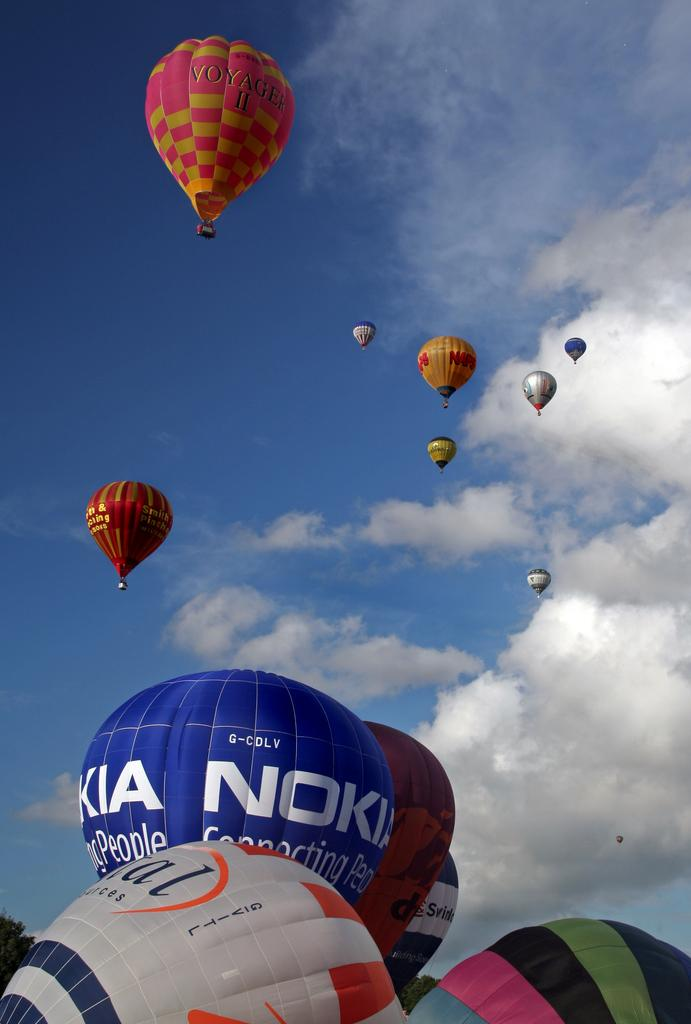<image>
Share a concise interpretation of the image provided. The pink and yellow Voyager II balloon is at the top of the image of many hot air balloons. 